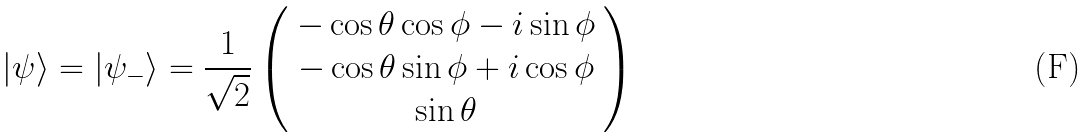<formula> <loc_0><loc_0><loc_500><loc_500>| \psi \rangle = | \psi _ { - } \rangle = \frac { 1 } { \sqrt { 2 } } \left ( \begin{array} { c } - \cos \theta \cos \phi - i \sin \phi \\ - \cos \theta \sin \phi + i \cos \phi \\ \sin \theta \end{array} \right )</formula> 